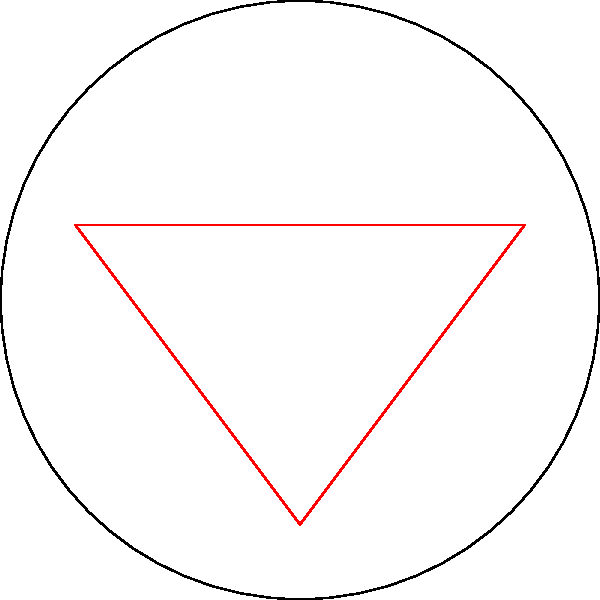On a spherical soccer field, Patrick "Diba" Nwegbo needs to pass the ball from point A to point B. Which path would result in the shortest distance for the ball to travel: the straight line (red) or the curved path (blue dashed line) following the surface's curvature? Explain your reasoning in terms of Non-Euclidean Geometry. To understand the shortest path on a curved surface, we need to consider the principles of Non-Euclidean Geometry:

1. In Euclidean geometry (flat surfaces), the shortest path between two points is always a straight line.

2. However, on a curved surface like a sphere (which represents our curved soccer field), the shortest path is not a straight line but a geodesic.

3. A geodesic is the curved equivalent of a straight line on a flat surface. It represents the path of least distance between two points on a curved surface.

4. On a sphere, geodesics are great circles - the largest possible circles that can be drawn on the sphere's surface.

5. In our diagram, the blue dashed line represents the geodesic (great circle arc) between points A and B on the curved surface.

6. The red line represents what would be the shortest path in Euclidean geometry (a straight line).

7. On the curved surface, the geodesic (blue dashed line) is actually shorter than the straight line (red line) when measured along the surface.

8. This is because the straight line would have to "cut through" the curved surface, while the geodesic follows the curvature of the surface.

9. In the context of soccer, this means that sometimes the optimal path for a pass or player movement might appear curved when viewed from above, but it's actually the shortest path on the curved field surface.

Therefore, for Patrick "Diba" Nwegbo's pass, the curved path (blue dashed line) following the surface's curvature would result in the shortest distance for the ball to travel on this spherical soccer field.
Answer: The curved path (geodesic) 